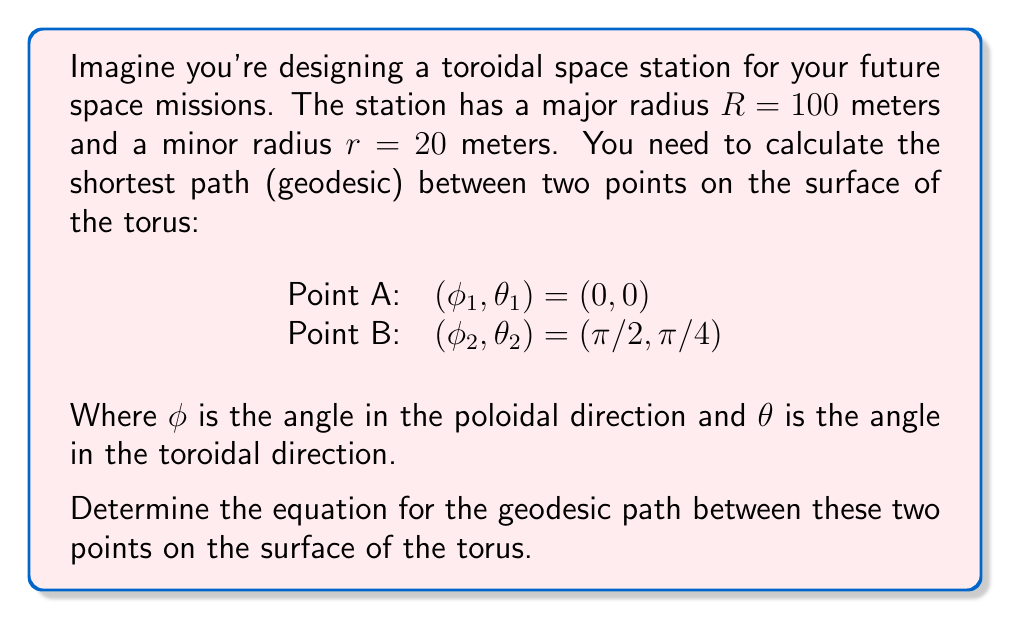Provide a solution to this math problem. To solve this problem, we'll follow these steps:

1) The metric for a torus with major radius $R$ and minor radius $r$ is given by:

   $$ds^2 = (R + r\cos\phi)^2 d\theta^2 + r^2 d\phi^2$$

2) The Euler-Lagrange equation for geodesics on a torus is:

   $$\frac{d}{d\lambda}\left((R + r\cos\phi)^2\frac{d\theta}{d\lambda}\right) = 0$$
   $$\frac{d}{d\lambda}\left(r^2\frac{d\phi}{d\lambda}\right) = (R + r\cos\phi)r\sin\phi\left(\frac{d\theta}{d\lambda}\right)^2$$

3) From the first equation, we can deduce:

   $$(R + r\cos\phi)^2\frac{d\theta}{d\lambda} = c$$

   Where $c$ is a constant.

4) Substituting this into the second equation:

   $$r^2\frac{d^2\phi}{d\lambda^2} = (R + r\cos\phi)r\sin\phi\frac{c^2}{(R + r\cos\phi)^4}$$

5) This differential equation doesn't have a simple analytical solution. However, we can approximate the geodesic using Clairaut's relation:

   $$\frac{\sin\alpha}{(R + r\cos\phi)} = \text{constant}$$

   Where $\alpha$ is the angle between the geodesic and the meridian ($\phi = \text{constant}$ curve).

6) For our specific case, we can write:

   $$\frac{\sin\alpha}{100 + 20\cos\phi} = k$$

   Where $k$ is a constant that depends on the initial conditions.

7) To find $k$, we need to use the boundary conditions. At the starting point $(0,0)$, we can calculate the initial direction of the geodesic:

   $$\tan\alpha = \frac{Rd\theta}{rd\phi} = \frac{100 \cdot \pi/4}{20 \cdot \pi/2} = 1$$

   So $\alpha = \pi/4$ at the starting point.

8) Therefore:

   $$k = \frac{\sin(\pi/4)}{100 + 20\cos(0)} = \frac{\sqrt{2}/2}{120} = \frac{\sqrt{2}}{240}$$

9) Our final equation for the geodesic is:

   $$\frac{\sin\alpha}{100 + 20\cos\phi} = \frac{\sqrt{2}}{240}$$

This equation implicitly defines the relationship between $\phi$ and $\theta$ along the geodesic.
Answer: The equation for the geodesic path between the two points on the surface of the torus is:

$$\frac{\sin\alpha}{100 + 20\cos\phi} = \frac{\sqrt{2}}{240}$$

Where $\alpha$ is the angle between the geodesic and the meridian at any point. 